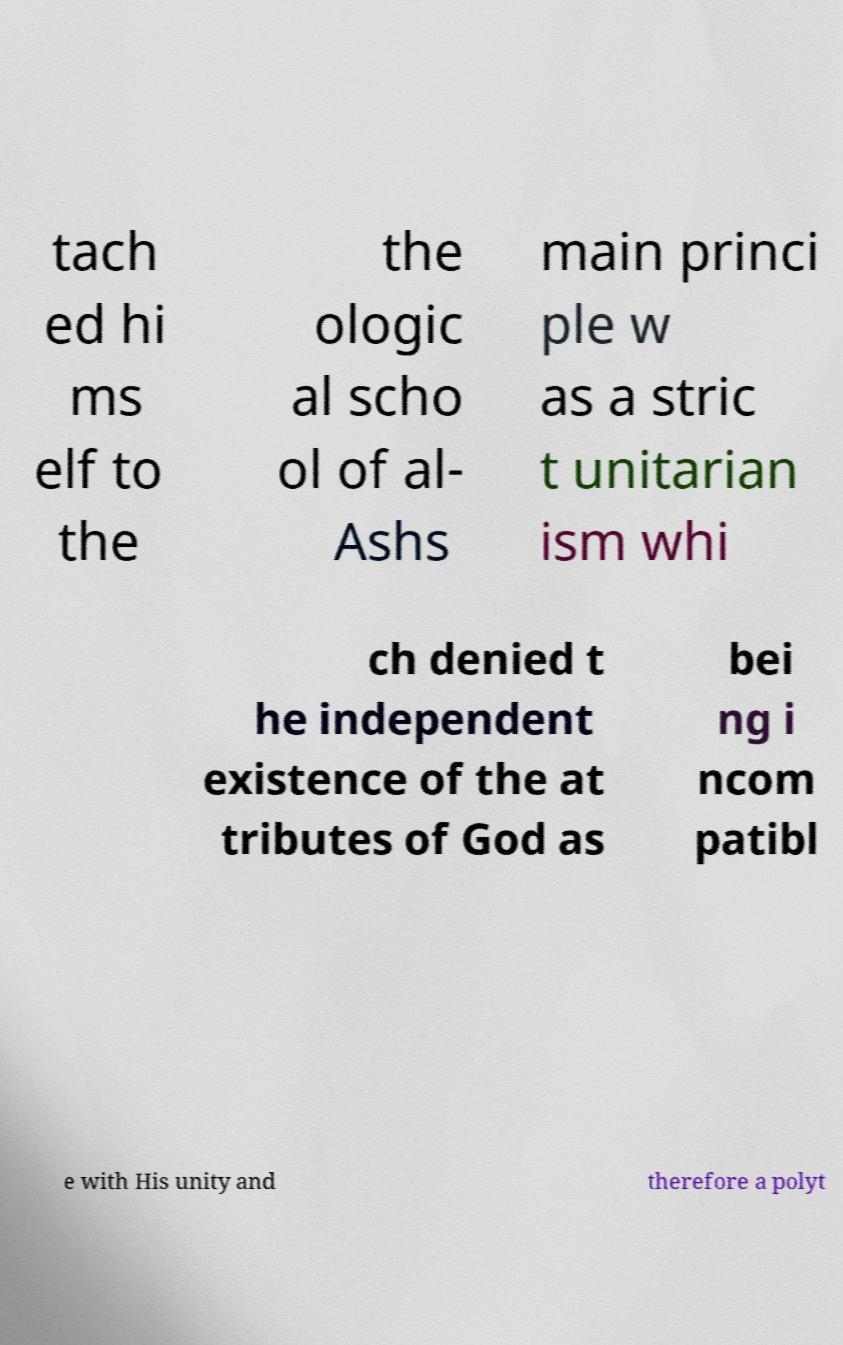For documentation purposes, I need the text within this image transcribed. Could you provide that? tach ed hi ms elf to the the ologic al scho ol of al- Ashs main princi ple w as a stric t unitarian ism whi ch denied t he independent existence of the at tributes of God as bei ng i ncom patibl e with His unity and therefore a polyt 